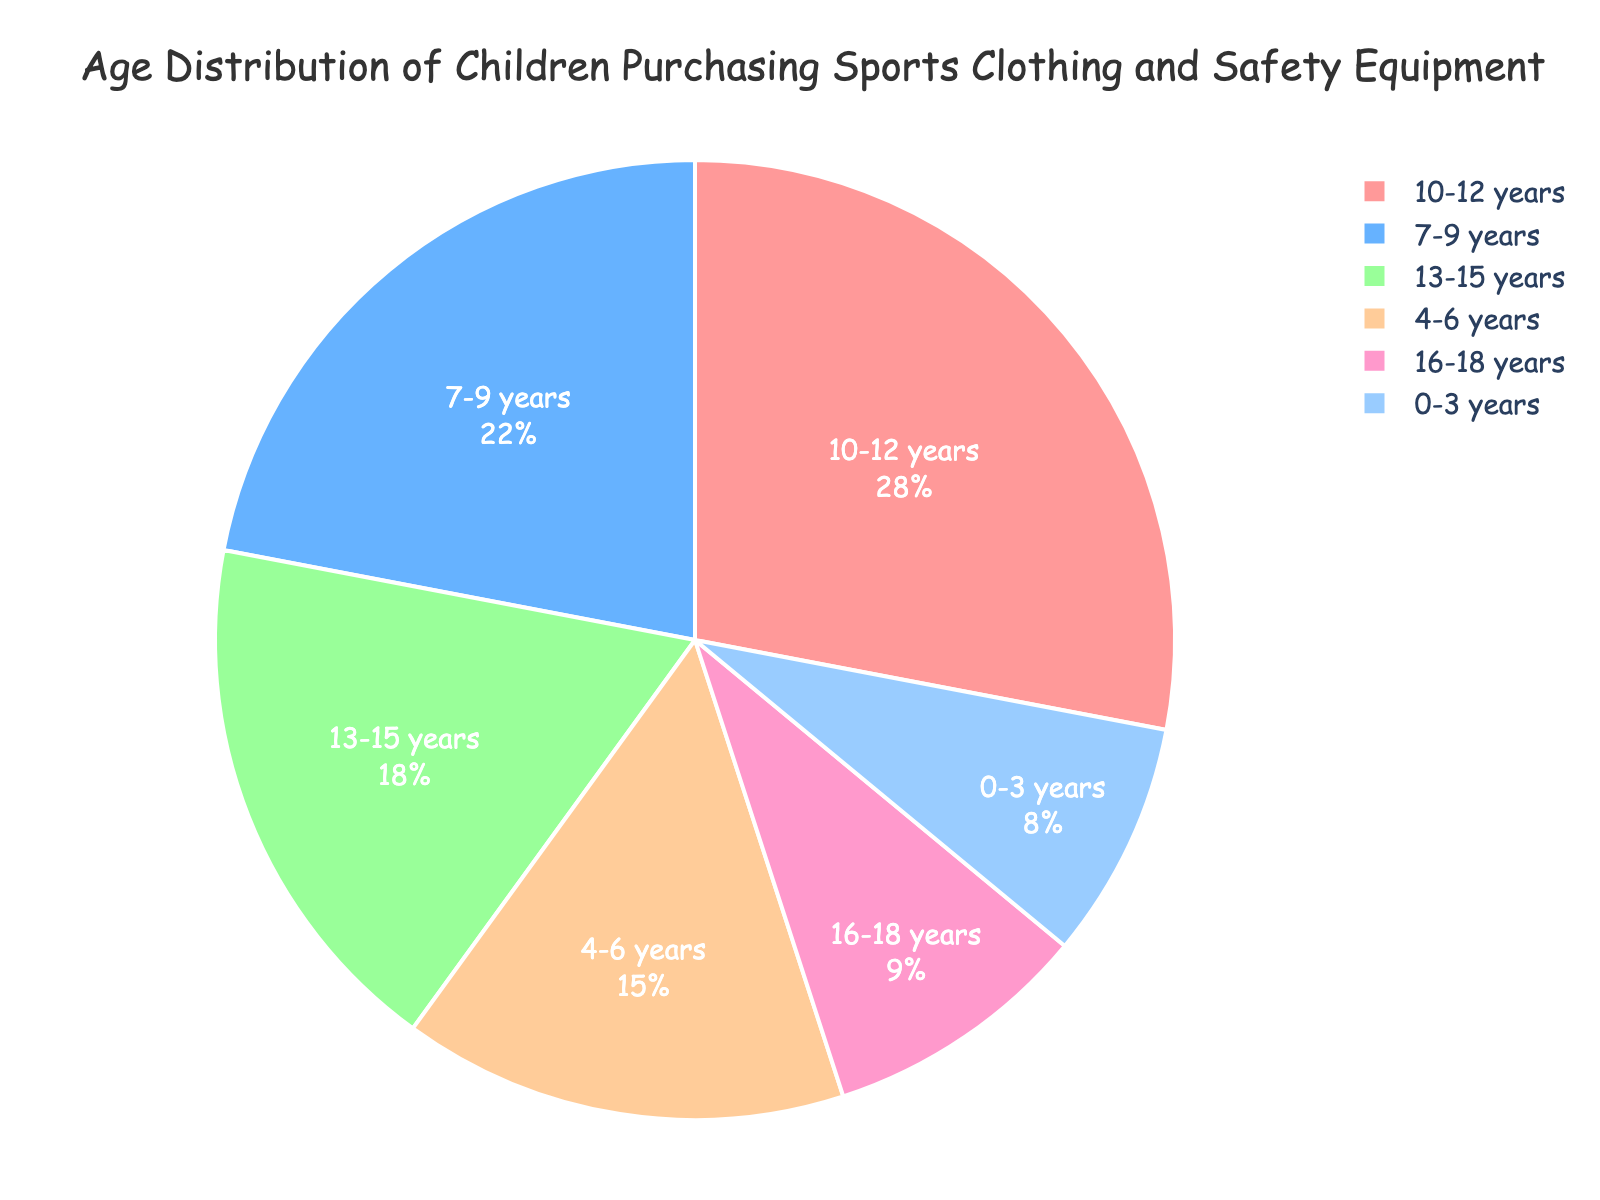what percentage of children aged 10-12 years are purchasing sports clothing and safety equipment? The chart shows each age group's percentage. Directly find the percentage listed for the 10-12 years age group.
Answer: 28% which age group has the smallest percentage of children purchasing sports clothing and safety equipment? Look for the slice that represents the smallest percentage on the chart.
Answer: 0-3 years how much greater is the percentage of children aged 10-12 years compared to children aged 16-18 years? Subtract the percentage of the 16-18 years age group from the 10-12 years age group. (28% - 9% = 19%)
Answer: 19% what is the total percentage of children aged 7-9 years and 13-15 years purchasing sports clothing and safety equipment? Add the percentages of the 7-9 years and 13-15 years groups together. (22% + 18% = 40%)
Answer: 40% which age group has the second largest percentage of children purchasing sports clothing and safety equipment? Identify the age group with the largest percentage first (10-12 years), then find the age group with the next highest percentage.
Answer: 7-9 years which color represents the age group 4-6 years? Look at the legend or labels to determine the color associated with the 4-6 years age group slice.
Answer: Blue how does the percentage of the 0-3 years age group compare to the 16-18 years age group? Compare their percentages directly from the chart.
Answer: less calculate the average percentage of the children aged under 10 years purchasing sports clothing and safety equipment. Sum up the percentages of under 10 years age groups and divide by the number of these groups. ((8% + 15% + 22%) / 3 = 15%)
Answer: 15% what is the combined percentage of children aged 0-3 years, 4-6 years, and 16-18 years? Add the percentages of age groups 0-3 years, 4-6 years, and 16-18 years. (8% + 15% + 9% = 32%)
Answer: 32% how does the percentage of the 13-15 years age group compare to the percentage of the 10-12 years age group? Compare their percentages directly from the chart and state if one is larger or smaller than the other.
Answer: smaller 